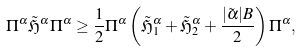<formula> <loc_0><loc_0><loc_500><loc_500>& \Pi ^ { \alpha } \tilde { \mathfrak H } ^ { \alpha } \Pi ^ { \alpha } \geq \frac { 1 } { 2 } \Pi ^ { \alpha } \left ( \tilde { \mathfrak H } _ { 1 } ^ { \alpha } + \tilde { \mathfrak H } _ { 2 } ^ { \alpha } + \frac { | \tilde { \alpha } | B } { 2 } \right ) \Pi ^ { \alpha } ,</formula> 